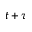Convert formula to latex. <formula><loc_0><loc_0><loc_500><loc_500>t + \tau</formula> 